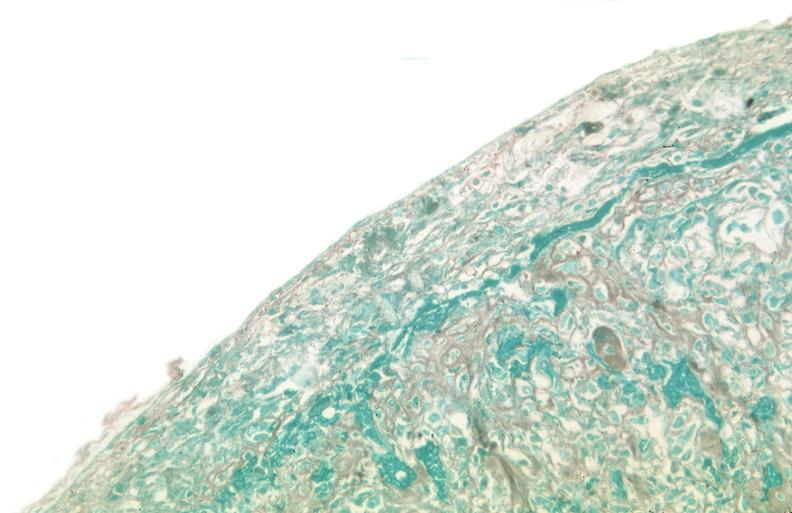s endometritis present?
Answer the question using a single word or phrase. No 